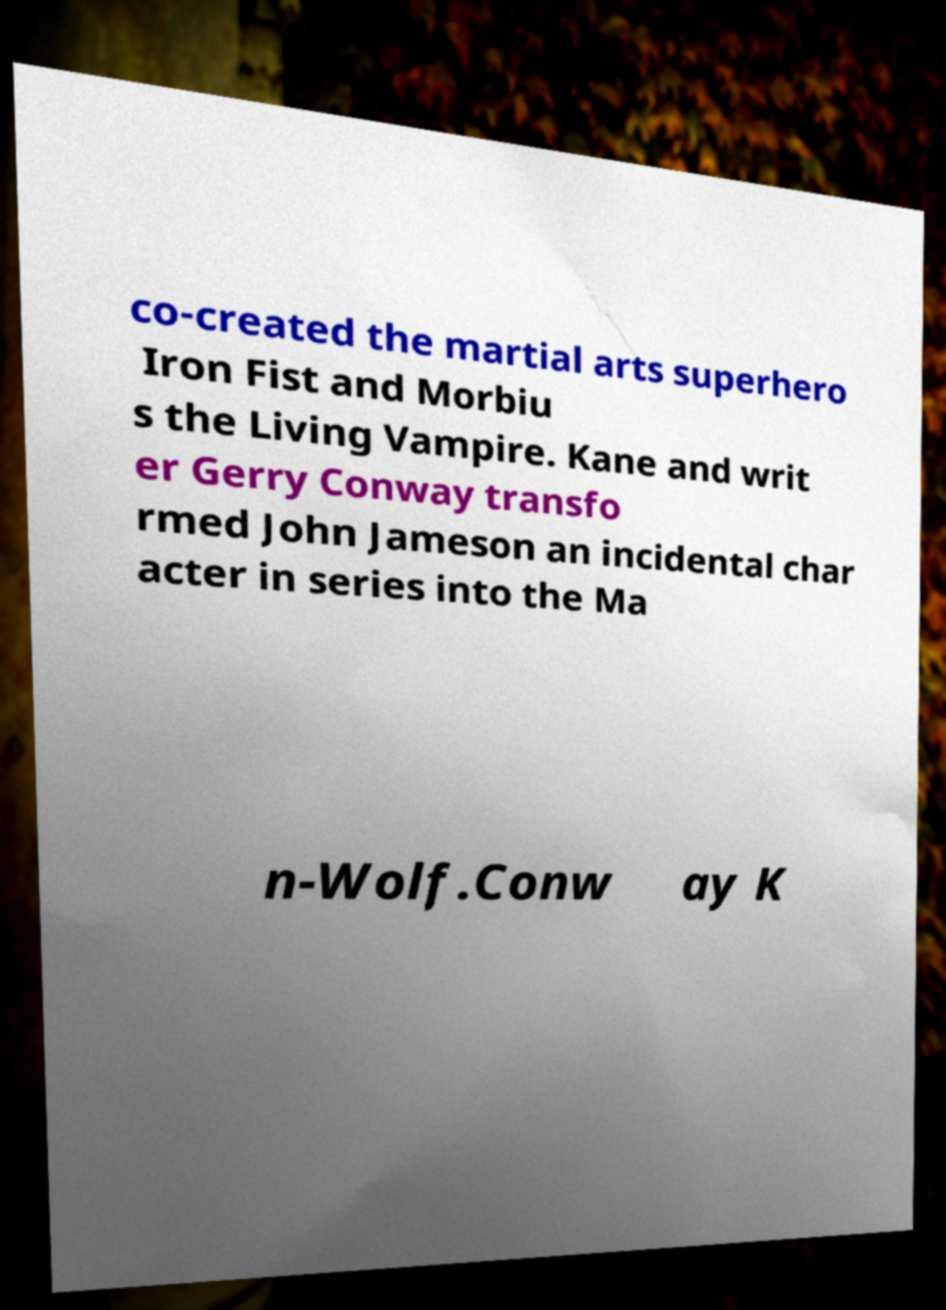Could you assist in decoding the text presented in this image and type it out clearly? co-created the martial arts superhero Iron Fist and Morbiu s the Living Vampire. Kane and writ er Gerry Conway transfo rmed John Jameson an incidental char acter in series into the Ma n-Wolf.Conw ay K 